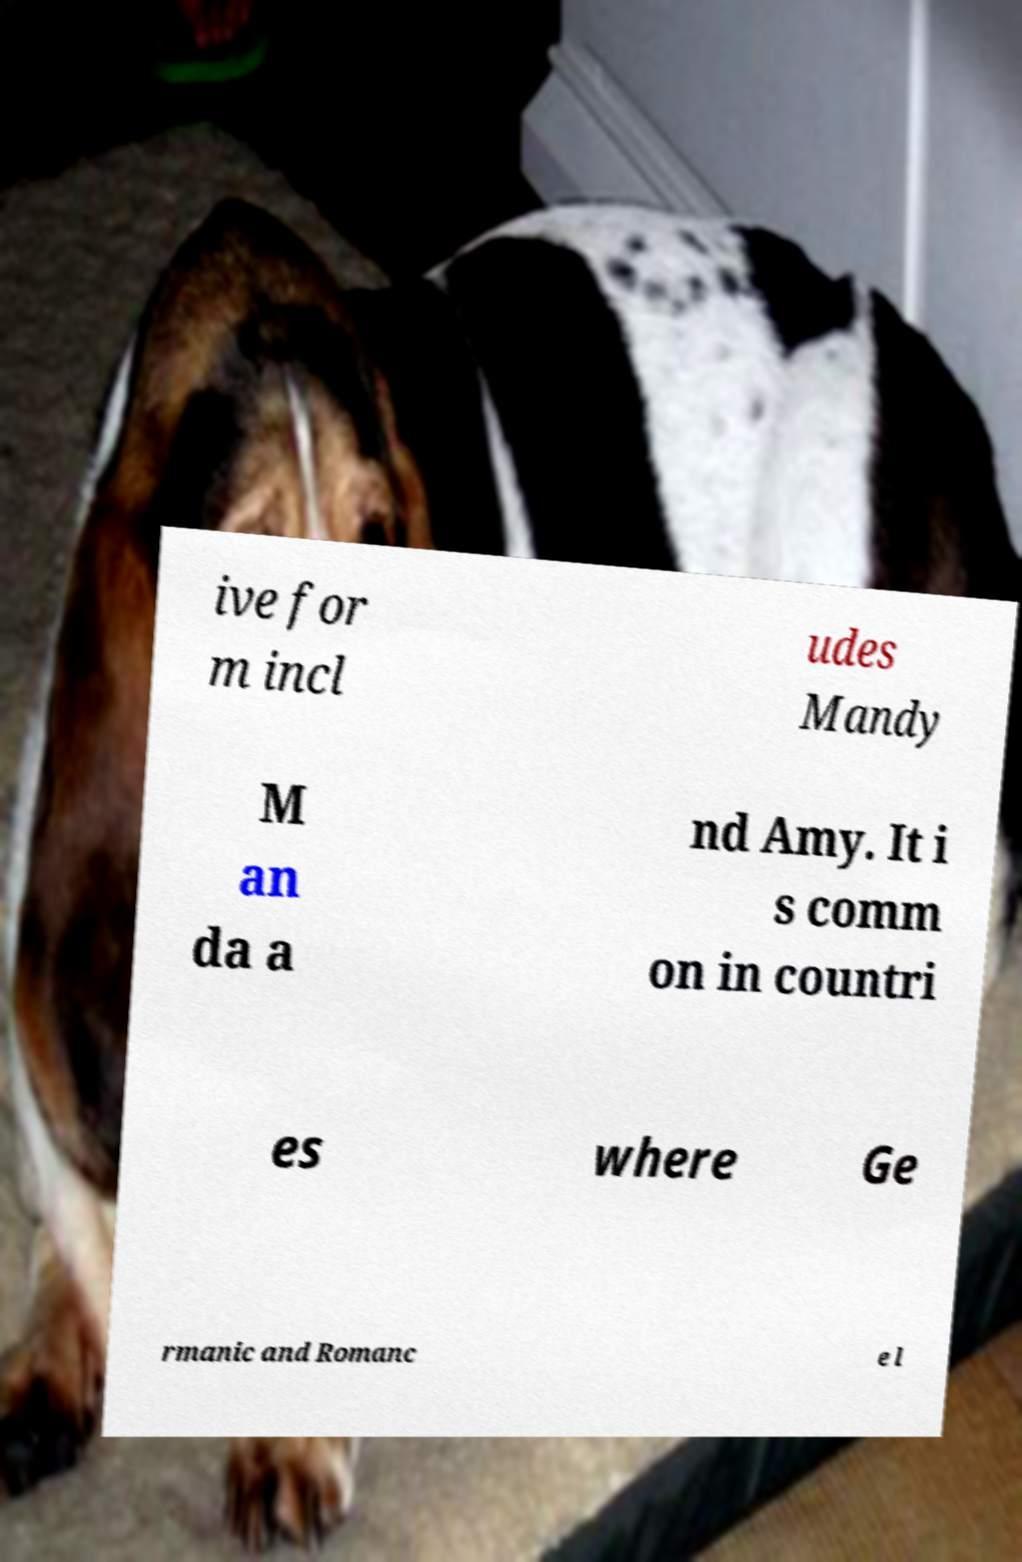What messages or text are displayed in this image? I need them in a readable, typed format. ive for m incl udes Mandy M an da a nd Amy. It i s comm on in countri es where Ge rmanic and Romanc e l 